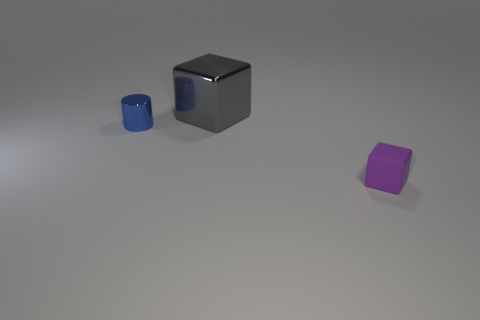Is there any other thing that is the same size as the gray object?
Provide a short and direct response. No. What is the shape of the small object to the right of the thing left of the cube that is behind the blue cylinder?
Your answer should be compact. Cube. The tiny thing left of the block behind the purple rubber block is what shape?
Your answer should be very brief. Cylinder. Are there any small cylinders that have the same material as the small purple cube?
Your response must be concise. No. How many gray things are shiny objects or small cylinders?
Ensure brevity in your answer.  1. The gray thing that is made of the same material as the small blue thing is what size?
Provide a succinct answer. Large. What number of blocks are tiny purple rubber things or large metallic things?
Ensure brevity in your answer.  2. Is the number of blue shiny cylinders greater than the number of yellow cylinders?
Your answer should be very brief. Yes. What number of other things have the same size as the blue metal thing?
Keep it short and to the point. 1. How many things are either objects that are behind the tiny purple rubber cube or small things?
Your response must be concise. 3. 